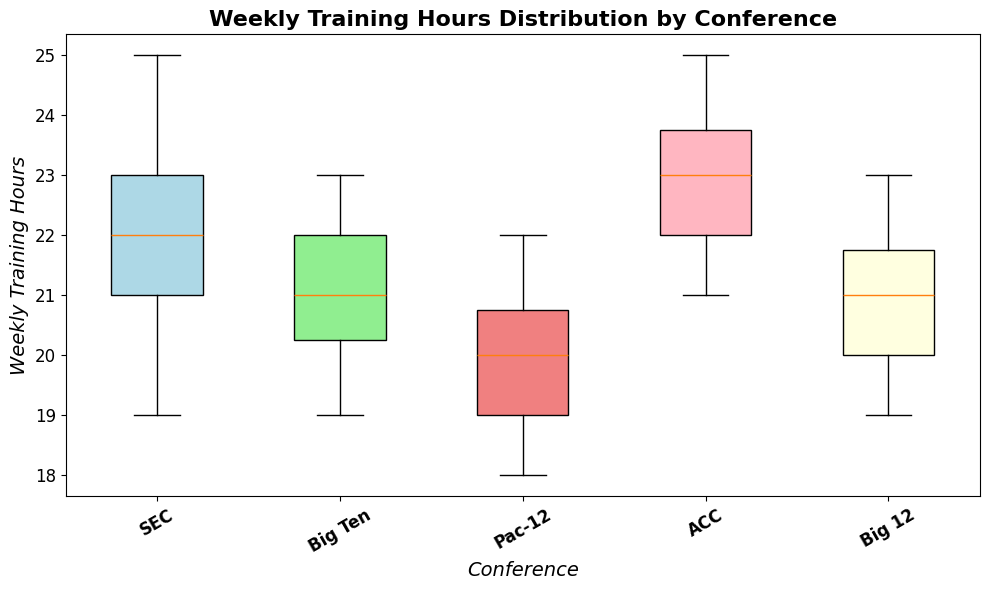Which conference has the highest median weekly training hours? To determine the conference with the highest median weekly training hours, observe the horizontal line within each box, representing the median value. The conference with the topmost line has the highest median.
Answer: ACC Compare the interquartile ranges (IQR) of the SEC and Pac-12 conferences. Which has a wider range? The IQR is represented by the height of the box from the first quartile (bottom of the box) to the third quartile (top of the box). By visually comparing these heights, we can determine that the SEC has a wider IQR than the Pac-12.
Answer: SEC Are there any outliers in the Big 12 conference? Outliers are usually indicated by small circles or dots outside the whiskers of the box plot. By examining the Big 12 conference, we can see if any such points exist.
Answer: No Which conference spends the least weekly training hours on average? To find the conference with the lowest average weekly training hours, visually compare the central location (median and mean appear close in symmetric data) of the boxes. The Pac-12 conference's box plot is positioned lower on the y-axis than others.
Answer: Pac-12 What is the range of weekly training hours for the Big Ten conference? The range is the difference between the maximum and the minimum values, represented by the top and bottom whiskers respectively. For the Big Ten, the maximum is at 23, and the minimum is at 19. So, the range is 23 - 19.
Answer: 4 Which conferences do not show any outliers in their training hours distribution? To identify these, look for conferences without any markers outside the whiskers; only SEC and Big Ten meet this criterion.
Answer: SEC, Big Ten What is the median weekly training time for the Pac-12? The median is shown by the horizontal line inside the box. For the Pac-12 conference, visually identify where the line falls within the box.
Answer: 20 Order the conferences by their median weekly training hours from highest to lowest. Medians are the lines inside each box. By comparing the positions of these lines, the order from highest to lowest is ACC, SEC, Big Ten, Big 12, Pac-12.
Answer: ACC, SEC, Big Ten, Big 12, Pac-12 Identify the conference where the majority of the data is within the narrowest range. This can be found by comparing the height of the boxes (the IQR). The Big Ten box is the shortest, indicating the narrowest range.
Answer: Big Ten 